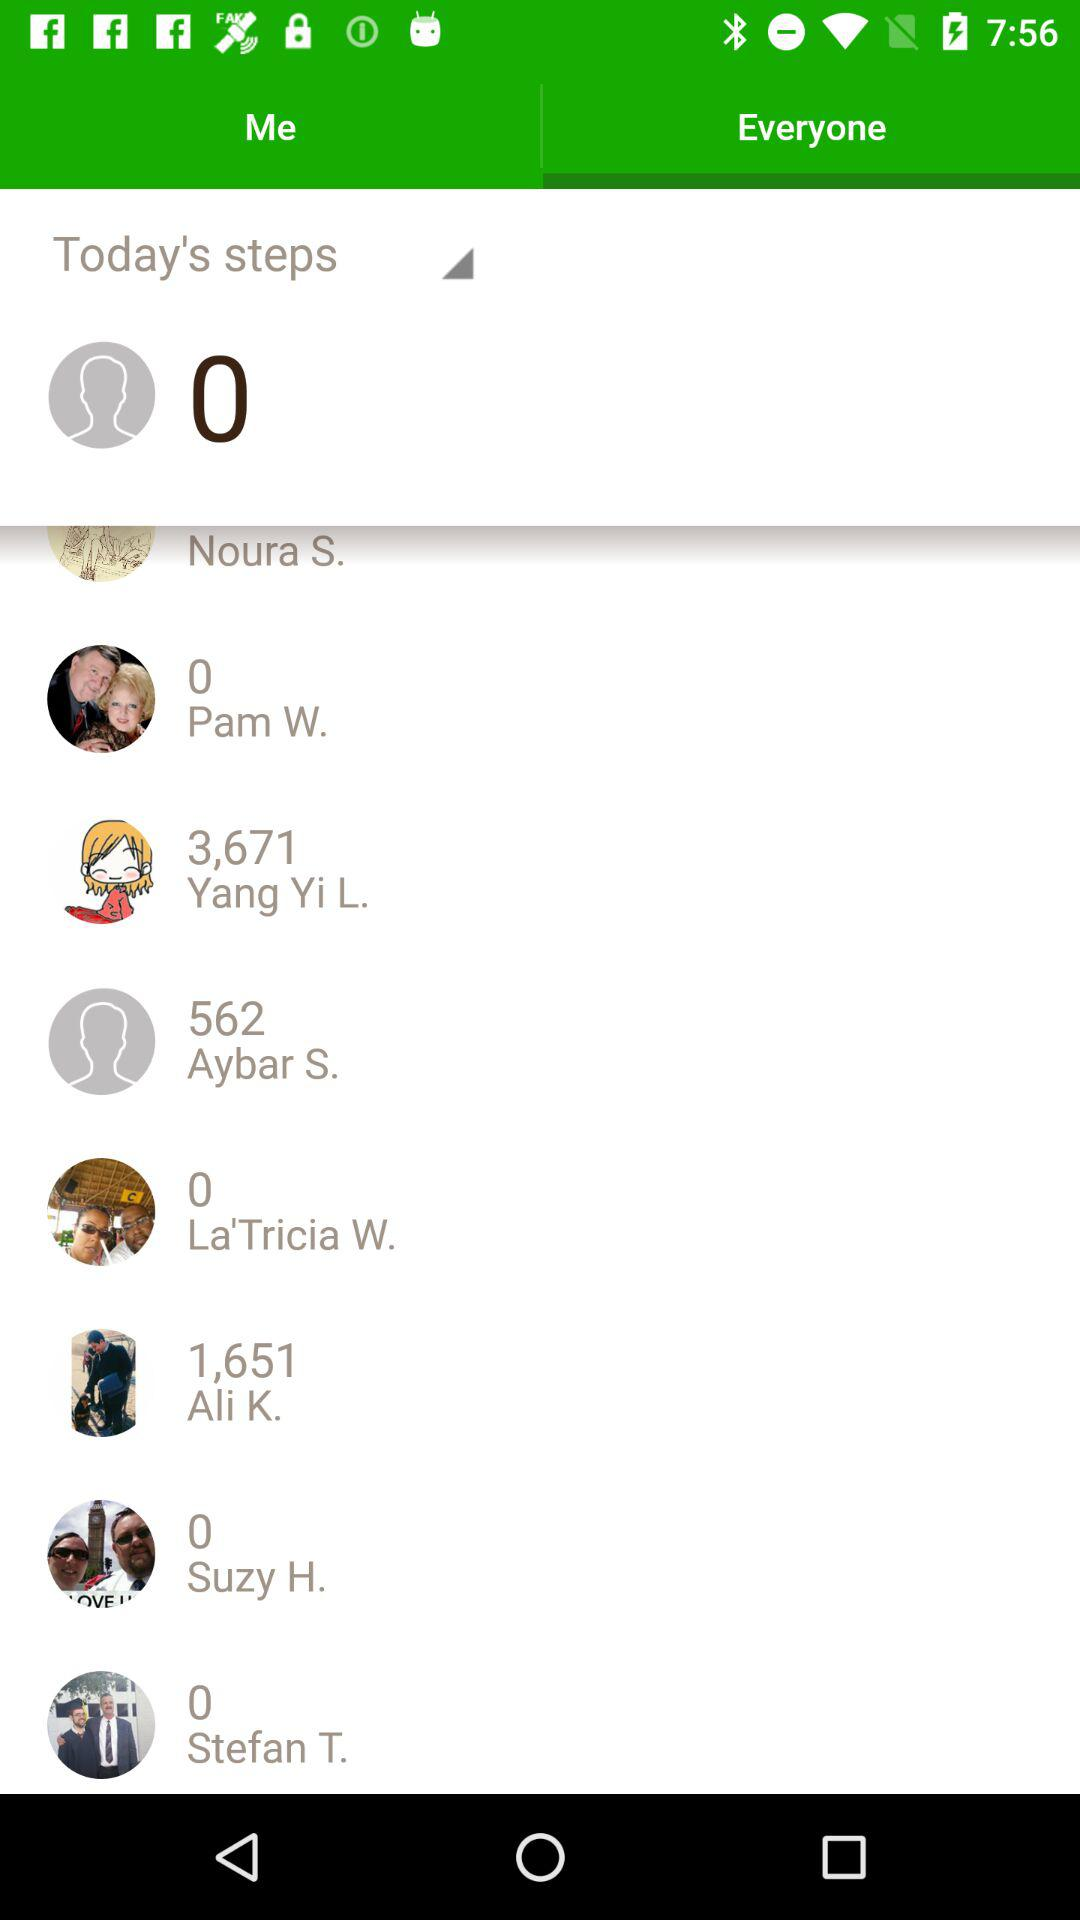How many steps did Yang Yi L. take? Yang Yi L. took 3,671 steps. 